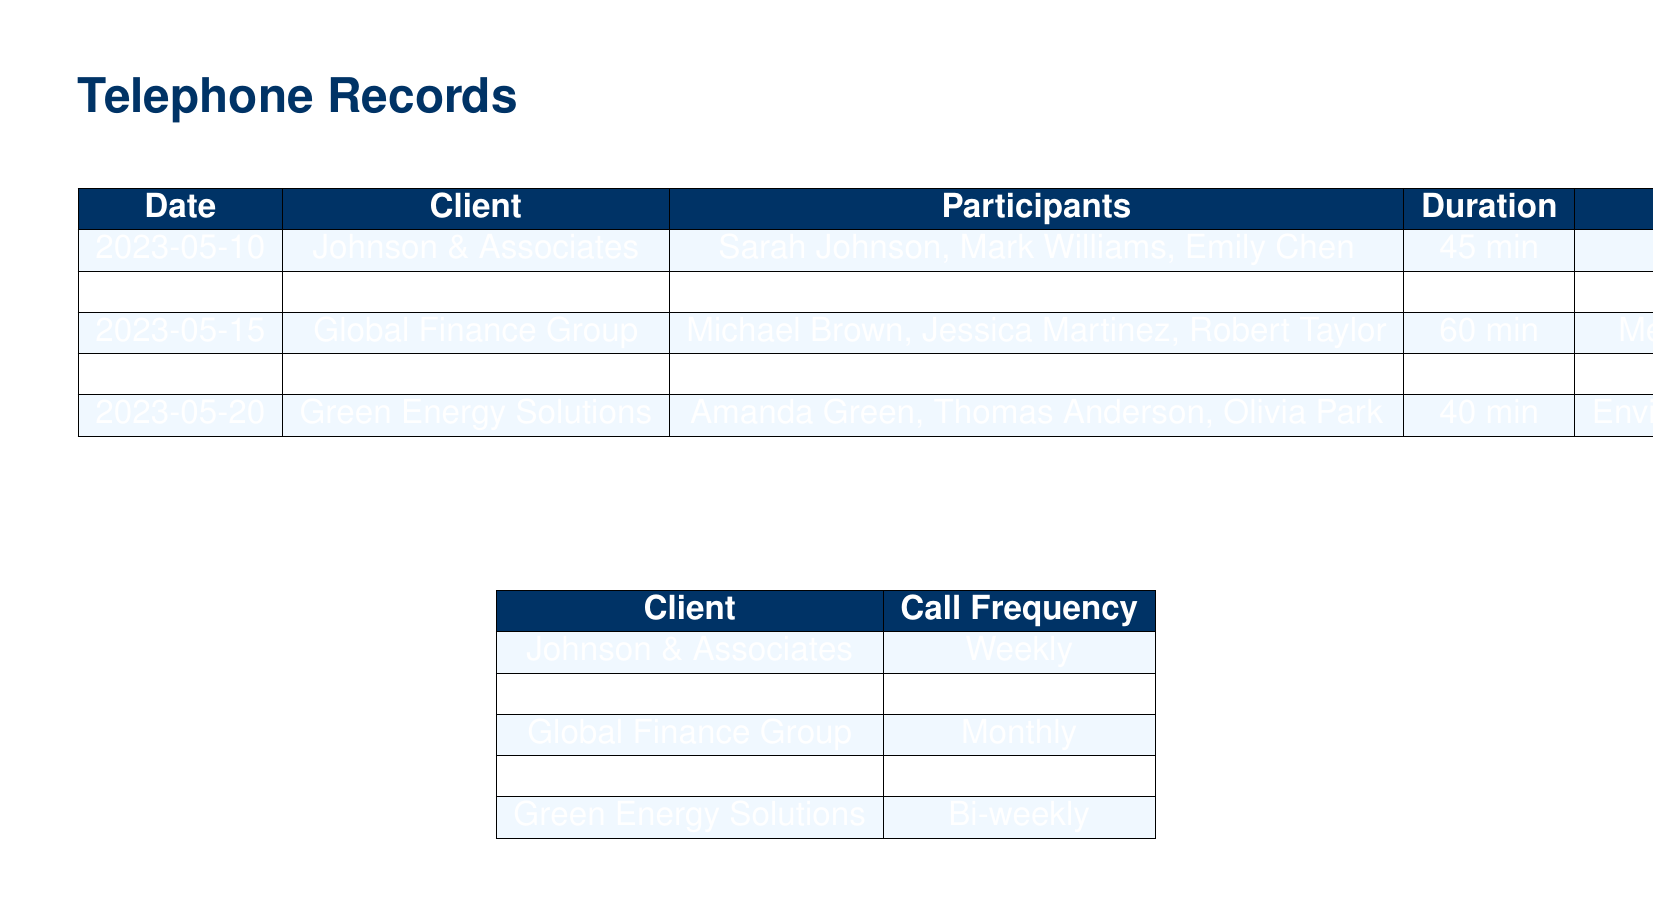What is the duration of the call with Johnson & Associates? The duration of the call is explicitly stated in the table for Johnson & Associates.
Answer: 45 min Who participated in the call on May 15? The participants for the call on May 15 are listed in the table corresponding to that date.
Answer: Michael Brown, Jessica Martinez, Robert Taylor What was the topic of the call with Tech Innovations Inc.? The topic of the call is provided alongside the participants and duration for Tech Innovations Inc.
Answer: Intellectual property dispute How often do calls occur with Global Finance Group? The call frequency for each client is specified in the second table, including Global Finance Group.
Answer: Monthly Which client had the shortest call duration? By comparing the durations listed in the first table, we can determine which call was the shortest.
Answer: Smith Family Trust What is the total number of participants in the call with Green Energy Solutions? The number of participants is counted from the list provided in the table for Green Energy Solutions.
Answer: 3 Which day did the call with Smith Family Trust occur? The date of the call is explicitly mentioned in the first table for the Smith Family Trust.
Answer: 2023-05-18 What is the frequency of communication with Johnson & Associates? The call frequency for Johnson & Associates is stated in the second table that outlines client communication.
Answer: Weekly 